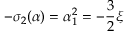<formula> <loc_0><loc_0><loc_500><loc_500>- \sigma _ { 2 } ( \alpha ) = \alpha _ { 1 } ^ { 2 } = - \frac { 3 } { 2 } \xi</formula> 